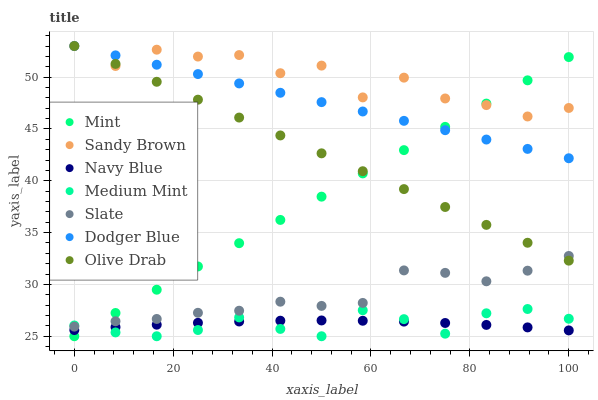Does Medium Mint have the minimum area under the curve?
Answer yes or no. Yes. Does Sandy Brown have the maximum area under the curve?
Answer yes or no. Yes. Does Mint have the minimum area under the curve?
Answer yes or no. No. Does Mint have the maximum area under the curve?
Answer yes or no. No. Is Dodger Blue the smoothest?
Answer yes or no. Yes. Is Sandy Brown the roughest?
Answer yes or no. Yes. Is Mint the smoothest?
Answer yes or no. No. Is Mint the roughest?
Answer yes or no. No. Does Medium Mint have the lowest value?
Answer yes or no. Yes. Does Slate have the lowest value?
Answer yes or no. No. Does Olive Drab have the highest value?
Answer yes or no. Yes. Does Mint have the highest value?
Answer yes or no. No. Is Slate less than Sandy Brown?
Answer yes or no. Yes. Is Olive Drab greater than Navy Blue?
Answer yes or no. Yes. Does Olive Drab intersect Dodger Blue?
Answer yes or no. Yes. Is Olive Drab less than Dodger Blue?
Answer yes or no. No. Is Olive Drab greater than Dodger Blue?
Answer yes or no. No. Does Slate intersect Sandy Brown?
Answer yes or no. No. 